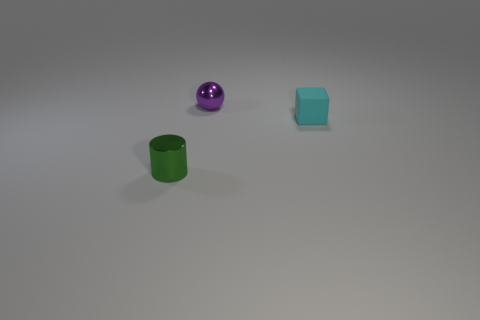Add 1 cyan blocks. How many objects exist? 4 Subtract all balls. How many objects are left? 2 Subtract all green cylinders. Subtract all small yellow balls. How many objects are left? 2 Add 3 purple shiny things. How many purple shiny things are left? 4 Add 2 green shiny cylinders. How many green shiny cylinders exist? 3 Subtract 0 yellow cylinders. How many objects are left? 3 